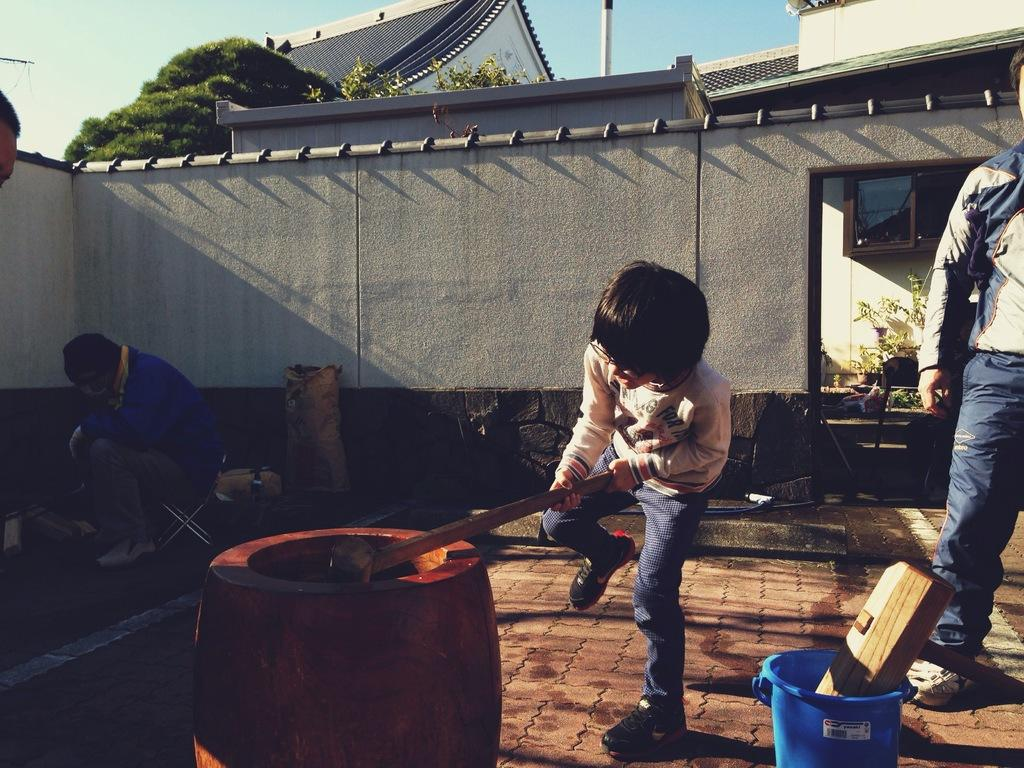What is the main subject of the image? The main subject of the image is a little kid. What is the kid doing in the image? The kid is mixing something in a barrel with a wooden stick. Can you describe the background of the image? There is a wall in the middle of the image and a green tree on the left side. What type of argument is the kid having with the tree in the image? There is no argument present in the image; the kid is simply mixing something in a barrel with a wooden stick. Can you see any writing on the wall in the image? There is no writing visible on the wall in the image. 